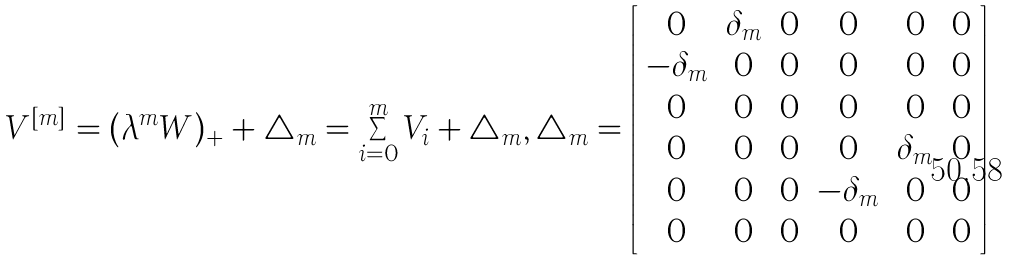<formula> <loc_0><loc_0><loc_500><loc_500>V ^ { [ m ] } = ( \lambda ^ { m } W ) _ { + } + \triangle _ { m } = \sum _ { i = 0 } ^ { m } V _ { i } + \triangle _ { m } , \triangle _ { m } = \left [ \begin{array} { c c c c c c } 0 & \delta _ { m } & 0 & 0 & 0 & 0 \\ - \delta _ { m } & 0 & 0 & 0 & 0 & 0 \\ 0 & 0 & 0 & 0 & 0 & 0 \\ 0 & 0 & 0 & 0 & \delta _ { m } & 0 \\ 0 & 0 & 0 & - \delta _ { m } & 0 & 0 \\ 0 & 0 & 0 & 0 & 0 & 0 \end{array} \right ]</formula> 